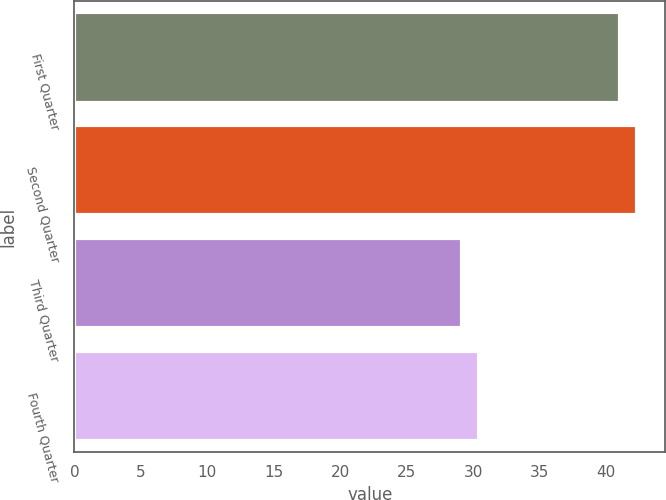<chart> <loc_0><loc_0><loc_500><loc_500><bar_chart><fcel>First Quarter<fcel>Second Quarter<fcel>Third Quarter<fcel>Fourth Quarter<nl><fcel>41.01<fcel>42.31<fcel>29.13<fcel>30.43<nl></chart> 